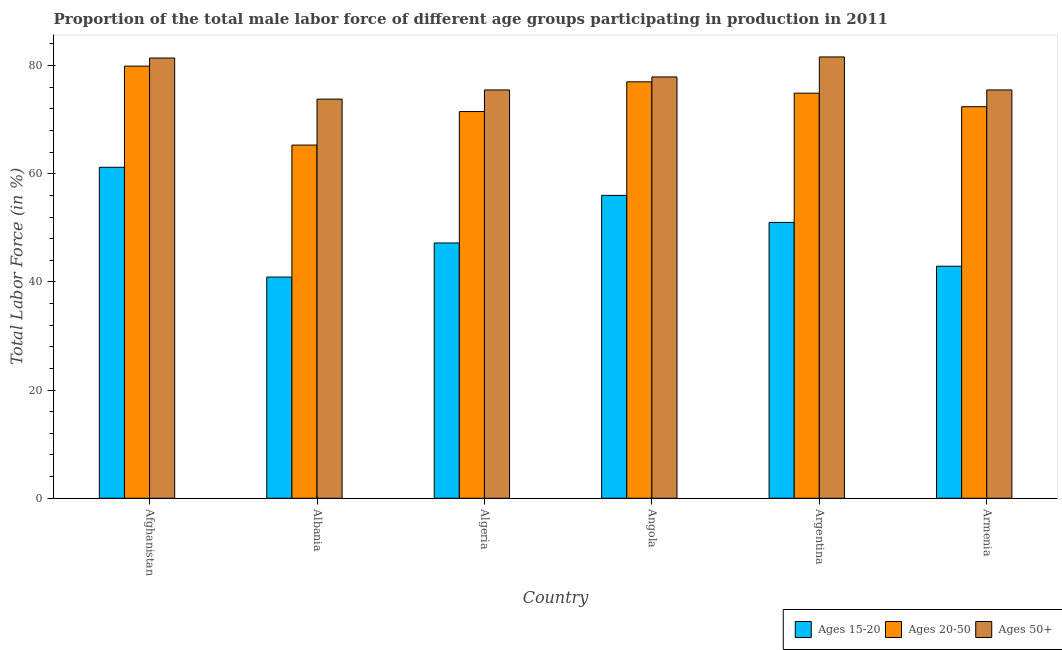How many different coloured bars are there?
Your answer should be very brief. 3. How many groups of bars are there?
Offer a very short reply. 6. Are the number of bars on each tick of the X-axis equal?
Make the answer very short. Yes. How many bars are there on the 2nd tick from the right?
Your response must be concise. 3. What is the label of the 5th group of bars from the left?
Your answer should be compact. Argentina. In how many cases, is the number of bars for a given country not equal to the number of legend labels?
Offer a very short reply. 0. What is the percentage of male labor force within the age group 20-50 in Albania?
Your answer should be very brief. 65.3. Across all countries, what is the maximum percentage of male labor force within the age group 15-20?
Provide a short and direct response. 61.2. Across all countries, what is the minimum percentage of male labor force within the age group 20-50?
Give a very brief answer. 65.3. In which country was the percentage of male labor force within the age group 20-50 maximum?
Your answer should be compact. Afghanistan. In which country was the percentage of male labor force above age 50 minimum?
Your answer should be compact. Albania. What is the total percentage of male labor force above age 50 in the graph?
Offer a terse response. 465.7. What is the difference between the percentage of male labor force above age 50 in Argentina and that in Armenia?
Offer a very short reply. 6.1. What is the difference between the percentage of male labor force above age 50 in Angola and the percentage of male labor force within the age group 20-50 in Argentina?
Provide a short and direct response. 3. What is the average percentage of male labor force within the age group 20-50 per country?
Keep it short and to the point. 73.5. What is the difference between the percentage of male labor force within the age group 15-20 and percentage of male labor force above age 50 in Algeria?
Make the answer very short. -28.3. What is the ratio of the percentage of male labor force within the age group 15-20 in Argentina to that in Armenia?
Your response must be concise. 1.19. Is the percentage of male labor force within the age group 15-20 in Algeria less than that in Armenia?
Your answer should be very brief. No. Is the difference between the percentage of male labor force within the age group 15-20 in Afghanistan and Albania greater than the difference between the percentage of male labor force within the age group 20-50 in Afghanistan and Albania?
Offer a terse response. Yes. What is the difference between the highest and the second highest percentage of male labor force above age 50?
Offer a terse response. 0.2. What is the difference between the highest and the lowest percentage of male labor force within the age group 20-50?
Provide a short and direct response. 14.6. What does the 2nd bar from the left in Armenia represents?
Your answer should be compact. Ages 20-50. What does the 1st bar from the right in Afghanistan represents?
Keep it short and to the point. Ages 50+. Is it the case that in every country, the sum of the percentage of male labor force within the age group 15-20 and percentage of male labor force within the age group 20-50 is greater than the percentage of male labor force above age 50?
Your answer should be very brief. Yes. Are all the bars in the graph horizontal?
Your response must be concise. No. How many countries are there in the graph?
Ensure brevity in your answer.  6. What is the difference between two consecutive major ticks on the Y-axis?
Ensure brevity in your answer.  20. Are the values on the major ticks of Y-axis written in scientific E-notation?
Provide a succinct answer. No. Does the graph contain grids?
Make the answer very short. No. How many legend labels are there?
Your response must be concise. 3. How are the legend labels stacked?
Ensure brevity in your answer.  Horizontal. What is the title of the graph?
Keep it short and to the point. Proportion of the total male labor force of different age groups participating in production in 2011. What is the label or title of the X-axis?
Keep it short and to the point. Country. What is the Total Labor Force (in %) in Ages 15-20 in Afghanistan?
Provide a short and direct response. 61.2. What is the Total Labor Force (in %) of Ages 20-50 in Afghanistan?
Offer a terse response. 79.9. What is the Total Labor Force (in %) in Ages 50+ in Afghanistan?
Your answer should be compact. 81.4. What is the Total Labor Force (in %) in Ages 15-20 in Albania?
Ensure brevity in your answer.  40.9. What is the Total Labor Force (in %) in Ages 20-50 in Albania?
Offer a terse response. 65.3. What is the Total Labor Force (in %) of Ages 50+ in Albania?
Your answer should be compact. 73.8. What is the Total Labor Force (in %) of Ages 15-20 in Algeria?
Keep it short and to the point. 47.2. What is the Total Labor Force (in %) of Ages 20-50 in Algeria?
Your answer should be compact. 71.5. What is the Total Labor Force (in %) in Ages 50+ in Algeria?
Give a very brief answer. 75.5. What is the Total Labor Force (in %) in Ages 15-20 in Angola?
Offer a terse response. 56. What is the Total Labor Force (in %) in Ages 20-50 in Angola?
Provide a short and direct response. 77. What is the Total Labor Force (in %) in Ages 50+ in Angola?
Make the answer very short. 77.9. What is the Total Labor Force (in %) of Ages 15-20 in Argentina?
Make the answer very short. 51. What is the Total Labor Force (in %) in Ages 20-50 in Argentina?
Provide a short and direct response. 74.9. What is the Total Labor Force (in %) of Ages 50+ in Argentina?
Your response must be concise. 81.6. What is the Total Labor Force (in %) in Ages 15-20 in Armenia?
Your answer should be compact. 42.9. What is the Total Labor Force (in %) in Ages 20-50 in Armenia?
Give a very brief answer. 72.4. What is the Total Labor Force (in %) of Ages 50+ in Armenia?
Your response must be concise. 75.5. Across all countries, what is the maximum Total Labor Force (in %) of Ages 15-20?
Provide a short and direct response. 61.2. Across all countries, what is the maximum Total Labor Force (in %) of Ages 20-50?
Provide a succinct answer. 79.9. Across all countries, what is the maximum Total Labor Force (in %) in Ages 50+?
Offer a terse response. 81.6. Across all countries, what is the minimum Total Labor Force (in %) in Ages 15-20?
Give a very brief answer. 40.9. Across all countries, what is the minimum Total Labor Force (in %) of Ages 20-50?
Your answer should be very brief. 65.3. Across all countries, what is the minimum Total Labor Force (in %) in Ages 50+?
Keep it short and to the point. 73.8. What is the total Total Labor Force (in %) of Ages 15-20 in the graph?
Give a very brief answer. 299.2. What is the total Total Labor Force (in %) in Ages 20-50 in the graph?
Your answer should be very brief. 441. What is the total Total Labor Force (in %) of Ages 50+ in the graph?
Your response must be concise. 465.7. What is the difference between the Total Labor Force (in %) in Ages 15-20 in Afghanistan and that in Albania?
Ensure brevity in your answer.  20.3. What is the difference between the Total Labor Force (in %) of Ages 15-20 in Afghanistan and that in Algeria?
Provide a short and direct response. 14. What is the difference between the Total Labor Force (in %) of Ages 15-20 in Afghanistan and that in Angola?
Provide a succinct answer. 5.2. What is the difference between the Total Labor Force (in %) in Ages 20-50 in Afghanistan and that in Angola?
Provide a succinct answer. 2.9. What is the difference between the Total Labor Force (in %) of Ages 15-20 in Afghanistan and that in Argentina?
Offer a very short reply. 10.2. What is the difference between the Total Labor Force (in %) of Ages 20-50 in Afghanistan and that in Argentina?
Ensure brevity in your answer.  5. What is the difference between the Total Labor Force (in %) in Ages 20-50 in Afghanistan and that in Armenia?
Your answer should be very brief. 7.5. What is the difference between the Total Labor Force (in %) in Ages 20-50 in Albania and that in Algeria?
Offer a terse response. -6.2. What is the difference between the Total Labor Force (in %) in Ages 15-20 in Albania and that in Angola?
Your answer should be compact. -15.1. What is the difference between the Total Labor Force (in %) of Ages 50+ in Albania and that in Angola?
Keep it short and to the point. -4.1. What is the difference between the Total Labor Force (in %) of Ages 15-20 in Albania and that in Argentina?
Your answer should be compact. -10.1. What is the difference between the Total Labor Force (in %) in Ages 15-20 in Albania and that in Armenia?
Give a very brief answer. -2. What is the difference between the Total Labor Force (in %) of Ages 20-50 in Albania and that in Armenia?
Your answer should be compact. -7.1. What is the difference between the Total Labor Force (in %) in Ages 50+ in Albania and that in Armenia?
Your answer should be very brief. -1.7. What is the difference between the Total Labor Force (in %) in Ages 15-20 in Algeria and that in Angola?
Provide a short and direct response. -8.8. What is the difference between the Total Labor Force (in %) of Ages 50+ in Algeria and that in Angola?
Offer a terse response. -2.4. What is the difference between the Total Labor Force (in %) of Ages 20-50 in Algeria and that in Argentina?
Your answer should be compact. -3.4. What is the difference between the Total Labor Force (in %) in Ages 50+ in Algeria and that in Argentina?
Your answer should be compact. -6.1. What is the difference between the Total Labor Force (in %) in Ages 15-20 in Algeria and that in Armenia?
Provide a succinct answer. 4.3. What is the difference between the Total Labor Force (in %) in Ages 50+ in Algeria and that in Armenia?
Offer a terse response. 0. What is the difference between the Total Labor Force (in %) of Ages 20-50 in Angola and that in Argentina?
Your answer should be compact. 2.1. What is the difference between the Total Labor Force (in %) of Ages 50+ in Angola and that in Argentina?
Your answer should be compact. -3.7. What is the difference between the Total Labor Force (in %) of Ages 20-50 in Angola and that in Armenia?
Your response must be concise. 4.6. What is the difference between the Total Labor Force (in %) of Ages 15-20 in Argentina and that in Armenia?
Keep it short and to the point. 8.1. What is the difference between the Total Labor Force (in %) in Ages 20-50 in Argentina and that in Armenia?
Your response must be concise. 2.5. What is the difference between the Total Labor Force (in %) in Ages 15-20 in Afghanistan and the Total Labor Force (in %) in Ages 50+ in Albania?
Provide a succinct answer. -12.6. What is the difference between the Total Labor Force (in %) in Ages 20-50 in Afghanistan and the Total Labor Force (in %) in Ages 50+ in Albania?
Provide a succinct answer. 6.1. What is the difference between the Total Labor Force (in %) of Ages 15-20 in Afghanistan and the Total Labor Force (in %) of Ages 50+ in Algeria?
Your response must be concise. -14.3. What is the difference between the Total Labor Force (in %) of Ages 15-20 in Afghanistan and the Total Labor Force (in %) of Ages 20-50 in Angola?
Offer a very short reply. -15.8. What is the difference between the Total Labor Force (in %) in Ages 15-20 in Afghanistan and the Total Labor Force (in %) in Ages 50+ in Angola?
Your answer should be compact. -16.7. What is the difference between the Total Labor Force (in %) of Ages 15-20 in Afghanistan and the Total Labor Force (in %) of Ages 20-50 in Argentina?
Provide a short and direct response. -13.7. What is the difference between the Total Labor Force (in %) of Ages 15-20 in Afghanistan and the Total Labor Force (in %) of Ages 50+ in Argentina?
Give a very brief answer. -20.4. What is the difference between the Total Labor Force (in %) in Ages 15-20 in Afghanistan and the Total Labor Force (in %) in Ages 20-50 in Armenia?
Your answer should be very brief. -11.2. What is the difference between the Total Labor Force (in %) in Ages 15-20 in Afghanistan and the Total Labor Force (in %) in Ages 50+ in Armenia?
Your answer should be compact. -14.3. What is the difference between the Total Labor Force (in %) of Ages 15-20 in Albania and the Total Labor Force (in %) of Ages 20-50 in Algeria?
Keep it short and to the point. -30.6. What is the difference between the Total Labor Force (in %) of Ages 15-20 in Albania and the Total Labor Force (in %) of Ages 50+ in Algeria?
Your answer should be compact. -34.6. What is the difference between the Total Labor Force (in %) in Ages 20-50 in Albania and the Total Labor Force (in %) in Ages 50+ in Algeria?
Your answer should be compact. -10.2. What is the difference between the Total Labor Force (in %) in Ages 15-20 in Albania and the Total Labor Force (in %) in Ages 20-50 in Angola?
Make the answer very short. -36.1. What is the difference between the Total Labor Force (in %) of Ages 15-20 in Albania and the Total Labor Force (in %) of Ages 50+ in Angola?
Provide a short and direct response. -37. What is the difference between the Total Labor Force (in %) in Ages 15-20 in Albania and the Total Labor Force (in %) in Ages 20-50 in Argentina?
Offer a terse response. -34. What is the difference between the Total Labor Force (in %) in Ages 15-20 in Albania and the Total Labor Force (in %) in Ages 50+ in Argentina?
Your answer should be compact. -40.7. What is the difference between the Total Labor Force (in %) in Ages 20-50 in Albania and the Total Labor Force (in %) in Ages 50+ in Argentina?
Ensure brevity in your answer.  -16.3. What is the difference between the Total Labor Force (in %) of Ages 15-20 in Albania and the Total Labor Force (in %) of Ages 20-50 in Armenia?
Your response must be concise. -31.5. What is the difference between the Total Labor Force (in %) in Ages 15-20 in Albania and the Total Labor Force (in %) in Ages 50+ in Armenia?
Provide a short and direct response. -34.6. What is the difference between the Total Labor Force (in %) of Ages 20-50 in Albania and the Total Labor Force (in %) of Ages 50+ in Armenia?
Your response must be concise. -10.2. What is the difference between the Total Labor Force (in %) of Ages 15-20 in Algeria and the Total Labor Force (in %) of Ages 20-50 in Angola?
Provide a short and direct response. -29.8. What is the difference between the Total Labor Force (in %) in Ages 15-20 in Algeria and the Total Labor Force (in %) in Ages 50+ in Angola?
Provide a short and direct response. -30.7. What is the difference between the Total Labor Force (in %) of Ages 20-50 in Algeria and the Total Labor Force (in %) of Ages 50+ in Angola?
Your response must be concise. -6.4. What is the difference between the Total Labor Force (in %) in Ages 15-20 in Algeria and the Total Labor Force (in %) in Ages 20-50 in Argentina?
Your answer should be very brief. -27.7. What is the difference between the Total Labor Force (in %) in Ages 15-20 in Algeria and the Total Labor Force (in %) in Ages 50+ in Argentina?
Provide a short and direct response. -34.4. What is the difference between the Total Labor Force (in %) of Ages 15-20 in Algeria and the Total Labor Force (in %) of Ages 20-50 in Armenia?
Ensure brevity in your answer.  -25.2. What is the difference between the Total Labor Force (in %) of Ages 15-20 in Algeria and the Total Labor Force (in %) of Ages 50+ in Armenia?
Ensure brevity in your answer.  -28.3. What is the difference between the Total Labor Force (in %) of Ages 20-50 in Algeria and the Total Labor Force (in %) of Ages 50+ in Armenia?
Offer a very short reply. -4. What is the difference between the Total Labor Force (in %) in Ages 15-20 in Angola and the Total Labor Force (in %) in Ages 20-50 in Argentina?
Offer a very short reply. -18.9. What is the difference between the Total Labor Force (in %) of Ages 15-20 in Angola and the Total Labor Force (in %) of Ages 50+ in Argentina?
Provide a succinct answer. -25.6. What is the difference between the Total Labor Force (in %) of Ages 15-20 in Angola and the Total Labor Force (in %) of Ages 20-50 in Armenia?
Offer a terse response. -16.4. What is the difference between the Total Labor Force (in %) of Ages 15-20 in Angola and the Total Labor Force (in %) of Ages 50+ in Armenia?
Offer a terse response. -19.5. What is the difference between the Total Labor Force (in %) in Ages 15-20 in Argentina and the Total Labor Force (in %) in Ages 20-50 in Armenia?
Your response must be concise. -21.4. What is the difference between the Total Labor Force (in %) of Ages 15-20 in Argentina and the Total Labor Force (in %) of Ages 50+ in Armenia?
Ensure brevity in your answer.  -24.5. What is the average Total Labor Force (in %) of Ages 15-20 per country?
Provide a short and direct response. 49.87. What is the average Total Labor Force (in %) in Ages 20-50 per country?
Your answer should be very brief. 73.5. What is the average Total Labor Force (in %) of Ages 50+ per country?
Your answer should be compact. 77.62. What is the difference between the Total Labor Force (in %) in Ages 15-20 and Total Labor Force (in %) in Ages 20-50 in Afghanistan?
Your answer should be compact. -18.7. What is the difference between the Total Labor Force (in %) in Ages 15-20 and Total Labor Force (in %) in Ages 50+ in Afghanistan?
Offer a terse response. -20.2. What is the difference between the Total Labor Force (in %) of Ages 20-50 and Total Labor Force (in %) of Ages 50+ in Afghanistan?
Provide a short and direct response. -1.5. What is the difference between the Total Labor Force (in %) in Ages 15-20 and Total Labor Force (in %) in Ages 20-50 in Albania?
Provide a short and direct response. -24.4. What is the difference between the Total Labor Force (in %) of Ages 15-20 and Total Labor Force (in %) of Ages 50+ in Albania?
Your answer should be very brief. -32.9. What is the difference between the Total Labor Force (in %) of Ages 15-20 and Total Labor Force (in %) of Ages 20-50 in Algeria?
Your answer should be very brief. -24.3. What is the difference between the Total Labor Force (in %) in Ages 15-20 and Total Labor Force (in %) in Ages 50+ in Algeria?
Offer a very short reply. -28.3. What is the difference between the Total Labor Force (in %) in Ages 20-50 and Total Labor Force (in %) in Ages 50+ in Algeria?
Offer a very short reply. -4. What is the difference between the Total Labor Force (in %) of Ages 15-20 and Total Labor Force (in %) of Ages 20-50 in Angola?
Your response must be concise. -21. What is the difference between the Total Labor Force (in %) of Ages 15-20 and Total Labor Force (in %) of Ages 50+ in Angola?
Your answer should be very brief. -21.9. What is the difference between the Total Labor Force (in %) of Ages 15-20 and Total Labor Force (in %) of Ages 20-50 in Argentina?
Ensure brevity in your answer.  -23.9. What is the difference between the Total Labor Force (in %) of Ages 15-20 and Total Labor Force (in %) of Ages 50+ in Argentina?
Make the answer very short. -30.6. What is the difference between the Total Labor Force (in %) of Ages 15-20 and Total Labor Force (in %) of Ages 20-50 in Armenia?
Offer a very short reply. -29.5. What is the difference between the Total Labor Force (in %) of Ages 15-20 and Total Labor Force (in %) of Ages 50+ in Armenia?
Your answer should be very brief. -32.6. What is the ratio of the Total Labor Force (in %) in Ages 15-20 in Afghanistan to that in Albania?
Provide a succinct answer. 1.5. What is the ratio of the Total Labor Force (in %) in Ages 20-50 in Afghanistan to that in Albania?
Offer a very short reply. 1.22. What is the ratio of the Total Labor Force (in %) in Ages 50+ in Afghanistan to that in Albania?
Give a very brief answer. 1.1. What is the ratio of the Total Labor Force (in %) of Ages 15-20 in Afghanistan to that in Algeria?
Keep it short and to the point. 1.3. What is the ratio of the Total Labor Force (in %) of Ages 20-50 in Afghanistan to that in Algeria?
Offer a terse response. 1.12. What is the ratio of the Total Labor Force (in %) in Ages 50+ in Afghanistan to that in Algeria?
Your answer should be very brief. 1.08. What is the ratio of the Total Labor Force (in %) in Ages 15-20 in Afghanistan to that in Angola?
Offer a terse response. 1.09. What is the ratio of the Total Labor Force (in %) in Ages 20-50 in Afghanistan to that in Angola?
Your answer should be very brief. 1.04. What is the ratio of the Total Labor Force (in %) in Ages 50+ in Afghanistan to that in Angola?
Your response must be concise. 1.04. What is the ratio of the Total Labor Force (in %) of Ages 20-50 in Afghanistan to that in Argentina?
Your answer should be very brief. 1.07. What is the ratio of the Total Labor Force (in %) of Ages 50+ in Afghanistan to that in Argentina?
Give a very brief answer. 1. What is the ratio of the Total Labor Force (in %) of Ages 15-20 in Afghanistan to that in Armenia?
Provide a short and direct response. 1.43. What is the ratio of the Total Labor Force (in %) of Ages 20-50 in Afghanistan to that in Armenia?
Your answer should be compact. 1.1. What is the ratio of the Total Labor Force (in %) of Ages 50+ in Afghanistan to that in Armenia?
Your answer should be very brief. 1.08. What is the ratio of the Total Labor Force (in %) of Ages 15-20 in Albania to that in Algeria?
Your response must be concise. 0.87. What is the ratio of the Total Labor Force (in %) of Ages 20-50 in Albania to that in Algeria?
Make the answer very short. 0.91. What is the ratio of the Total Labor Force (in %) of Ages 50+ in Albania to that in Algeria?
Offer a terse response. 0.98. What is the ratio of the Total Labor Force (in %) of Ages 15-20 in Albania to that in Angola?
Provide a short and direct response. 0.73. What is the ratio of the Total Labor Force (in %) in Ages 20-50 in Albania to that in Angola?
Your response must be concise. 0.85. What is the ratio of the Total Labor Force (in %) in Ages 50+ in Albania to that in Angola?
Offer a terse response. 0.95. What is the ratio of the Total Labor Force (in %) in Ages 15-20 in Albania to that in Argentina?
Give a very brief answer. 0.8. What is the ratio of the Total Labor Force (in %) of Ages 20-50 in Albania to that in Argentina?
Offer a terse response. 0.87. What is the ratio of the Total Labor Force (in %) of Ages 50+ in Albania to that in Argentina?
Provide a short and direct response. 0.9. What is the ratio of the Total Labor Force (in %) in Ages 15-20 in Albania to that in Armenia?
Your answer should be very brief. 0.95. What is the ratio of the Total Labor Force (in %) in Ages 20-50 in Albania to that in Armenia?
Your answer should be compact. 0.9. What is the ratio of the Total Labor Force (in %) in Ages 50+ in Albania to that in Armenia?
Your response must be concise. 0.98. What is the ratio of the Total Labor Force (in %) in Ages 15-20 in Algeria to that in Angola?
Provide a succinct answer. 0.84. What is the ratio of the Total Labor Force (in %) of Ages 20-50 in Algeria to that in Angola?
Make the answer very short. 0.93. What is the ratio of the Total Labor Force (in %) in Ages 50+ in Algeria to that in Angola?
Provide a succinct answer. 0.97. What is the ratio of the Total Labor Force (in %) of Ages 15-20 in Algeria to that in Argentina?
Offer a very short reply. 0.93. What is the ratio of the Total Labor Force (in %) of Ages 20-50 in Algeria to that in Argentina?
Your answer should be compact. 0.95. What is the ratio of the Total Labor Force (in %) of Ages 50+ in Algeria to that in Argentina?
Give a very brief answer. 0.93. What is the ratio of the Total Labor Force (in %) of Ages 15-20 in Algeria to that in Armenia?
Your answer should be compact. 1.1. What is the ratio of the Total Labor Force (in %) of Ages 20-50 in Algeria to that in Armenia?
Offer a terse response. 0.99. What is the ratio of the Total Labor Force (in %) of Ages 15-20 in Angola to that in Argentina?
Your answer should be compact. 1.1. What is the ratio of the Total Labor Force (in %) of Ages 20-50 in Angola to that in Argentina?
Ensure brevity in your answer.  1.03. What is the ratio of the Total Labor Force (in %) in Ages 50+ in Angola to that in Argentina?
Make the answer very short. 0.95. What is the ratio of the Total Labor Force (in %) in Ages 15-20 in Angola to that in Armenia?
Provide a short and direct response. 1.31. What is the ratio of the Total Labor Force (in %) of Ages 20-50 in Angola to that in Armenia?
Offer a very short reply. 1.06. What is the ratio of the Total Labor Force (in %) of Ages 50+ in Angola to that in Armenia?
Give a very brief answer. 1.03. What is the ratio of the Total Labor Force (in %) in Ages 15-20 in Argentina to that in Armenia?
Make the answer very short. 1.19. What is the ratio of the Total Labor Force (in %) of Ages 20-50 in Argentina to that in Armenia?
Keep it short and to the point. 1.03. What is the ratio of the Total Labor Force (in %) in Ages 50+ in Argentina to that in Armenia?
Offer a very short reply. 1.08. What is the difference between the highest and the second highest Total Labor Force (in %) of Ages 15-20?
Your response must be concise. 5.2. What is the difference between the highest and the second highest Total Labor Force (in %) in Ages 50+?
Provide a succinct answer. 0.2. What is the difference between the highest and the lowest Total Labor Force (in %) of Ages 15-20?
Offer a terse response. 20.3. What is the difference between the highest and the lowest Total Labor Force (in %) of Ages 50+?
Offer a terse response. 7.8. 